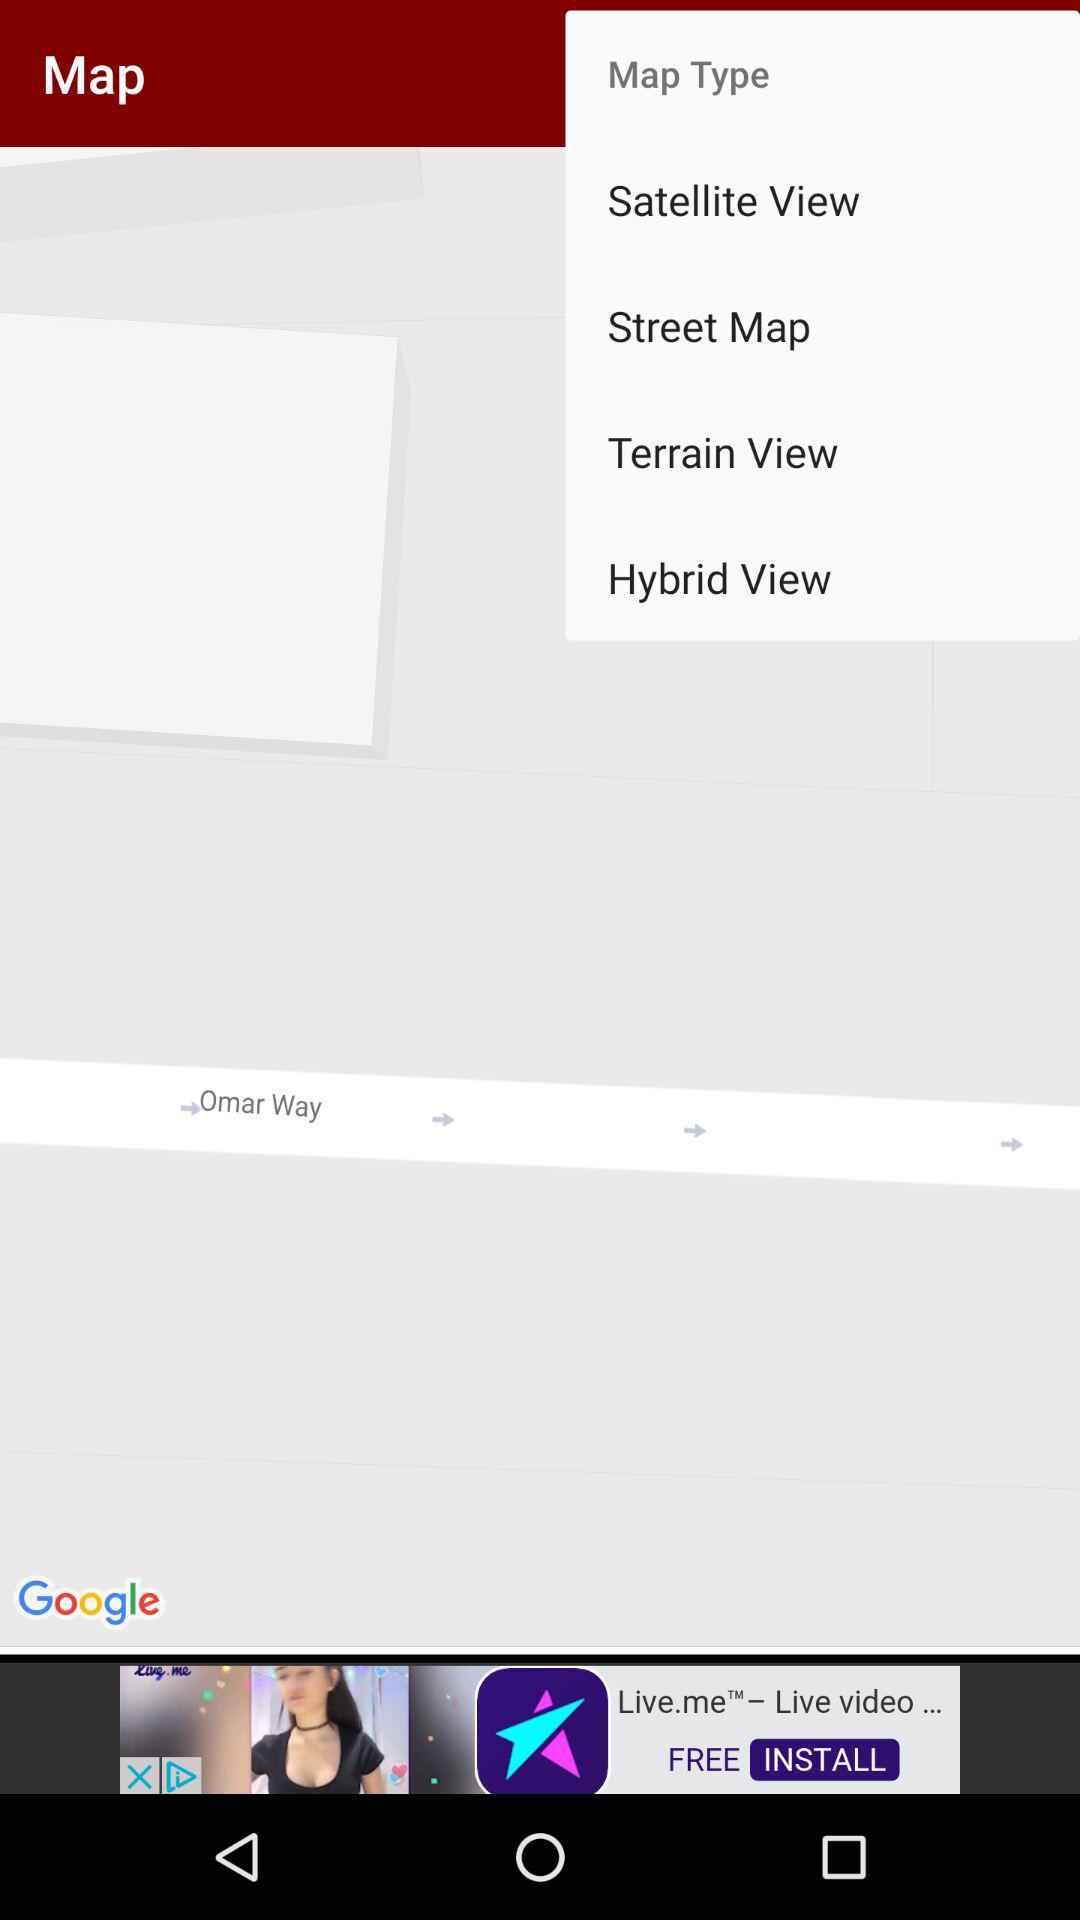How many map types are there?
Answer the question using a single word or phrase. 4 